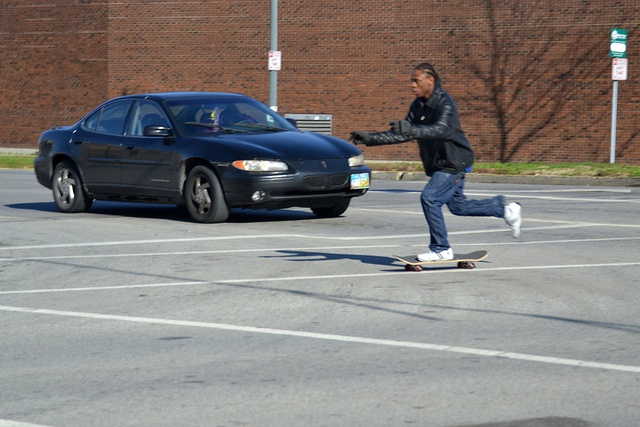Describe the objects in this image and their specific colors. I can see car in brown, black, navy, darkblue, and gray tones, people in brown, black, gray, navy, and darkblue tones, and skateboard in brown, gray, tan, darkgray, and black tones in this image. 